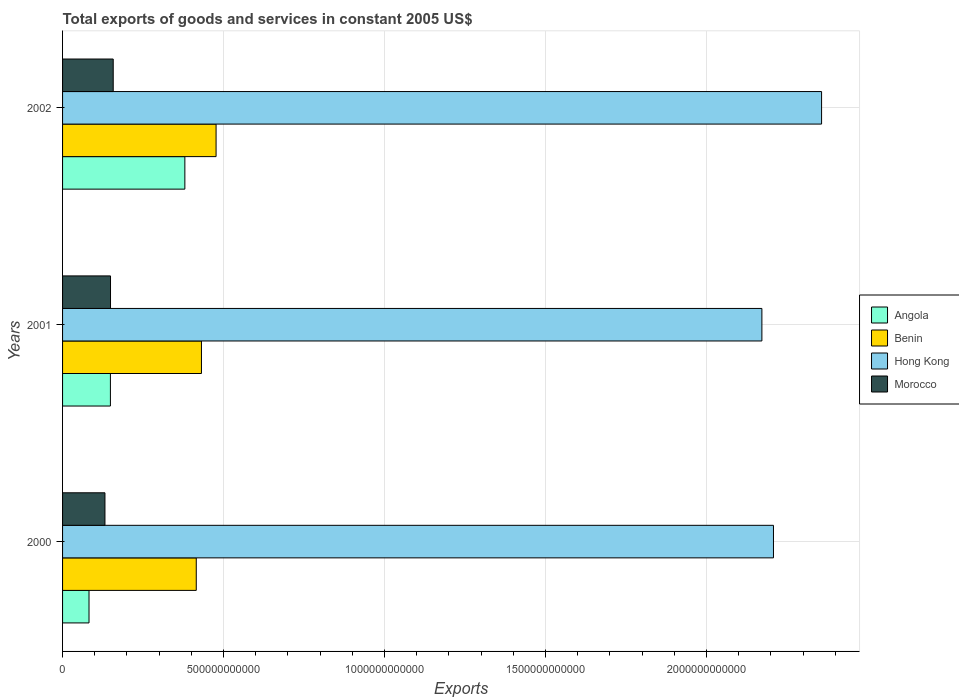How many different coloured bars are there?
Give a very brief answer. 4. How many groups of bars are there?
Your response must be concise. 3. Are the number of bars per tick equal to the number of legend labels?
Keep it short and to the point. Yes. What is the label of the 2nd group of bars from the top?
Make the answer very short. 2001. What is the total exports of goods and services in Benin in 2000?
Offer a very short reply. 4.15e+11. Across all years, what is the maximum total exports of goods and services in Benin?
Provide a short and direct response. 4.77e+11. Across all years, what is the minimum total exports of goods and services in Hong Kong?
Make the answer very short. 2.17e+12. In which year was the total exports of goods and services in Hong Kong maximum?
Make the answer very short. 2002. What is the total total exports of goods and services in Hong Kong in the graph?
Your answer should be very brief. 6.74e+12. What is the difference between the total exports of goods and services in Angola in 2000 and that in 2002?
Your answer should be very brief. -2.98e+11. What is the difference between the total exports of goods and services in Benin in 2001 and the total exports of goods and services in Morocco in 2002?
Your answer should be very brief. 2.74e+11. What is the average total exports of goods and services in Hong Kong per year?
Provide a short and direct response. 2.25e+12. In the year 2001, what is the difference between the total exports of goods and services in Angola and total exports of goods and services in Morocco?
Offer a very short reply. -3.27e+08. What is the ratio of the total exports of goods and services in Hong Kong in 2000 to that in 2002?
Offer a very short reply. 0.94. Is the total exports of goods and services in Morocco in 2001 less than that in 2002?
Your answer should be very brief. Yes. Is the difference between the total exports of goods and services in Angola in 2000 and 2001 greater than the difference between the total exports of goods and services in Morocco in 2000 and 2001?
Offer a very short reply. No. What is the difference between the highest and the second highest total exports of goods and services in Hong Kong?
Keep it short and to the point. 1.49e+11. What is the difference between the highest and the lowest total exports of goods and services in Benin?
Your answer should be very brief. 6.15e+1. What does the 1st bar from the top in 2001 represents?
Keep it short and to the point. Morocco. What does the 2nd bar from the bottom in 2000 represents?
Provide a short and direct response. Benin. Is it the case that in every year, the sum of the total exports of goods and services in Hong Kong and total exports of goods and services in Angola is greater than the total exports of goods and services in Benin?
Your response must be concise. Yes. How many bars are there?
Your answer should be very brief. 12. How many years are there in the graph?
Provide a short and direct response. 3. What is the difference between two consecutive major ticks on the X-axis?
Provide a short and direct response. 5.00e+11. Does the graph contain any zero values?
Offer a terse response. No. Does the graph contain grids?
Your answer should be compact. Yes. Where does the legend appear in the graph?
Give a very brief answer. Center right. How many legend labels are there?
Provide a short and direct response. 4. How are the legend labels stacked?
Your response must be concise. Vertical. What is the title of the graph?
Your response must be concise. Total exports of goods and services in constant 2005 US$. Does "Armenia" appear as one of the legend labels in the graph?
Provide a short and direct response. No. What is the label or title of the X-axis?
Your answer should be compact. Exports. What is the Exports in Angola in 2000?
Offer a very short reply. 8.22e+1. What is the Exports of Benin in 2000?
Your answer should be very brief. 4.15e+11. What is the Exports of Hong Kong in 2000?
Give a very brief answer. 2.21e+12. What is the Exports of Morocco in 2000?
Make the answer very short. 1.32e+11. What is the Exports of Angola in 2001?
Make the answer very short. 1.49e+11. What is the Exports of Benin in 2001?
Make the answer very short. 4.31e+11. What is the Exports in Hong Kong in 2001?
Offer a terse response. 2.17e+12. What is the Exports in Morocco in 2001?
Your answer should be very brief. 1.49e+11. What is the Exports in Angola in 2002?
Ensure brevity in your answer.  3.80e+11. What is the Exports in Benin in 2002?
Give a very brief answer. 4.77e+11. What is the Exports in Hong Kong in 2002?
Give a very brief answer. 2.36e+12. What is the Exports in Morocco in 2002?
Your answer should be compact. 1.57e+11. Across all years, what is the maximum Exports of Angola?
Keep it short and to the point. 3.80e+11. Across all years, what is the maximum Exports in Benin?
Offer a terse response. 4.77e+11. Across all years, what is the maximum Exports of Hong Kong?
Provide a short and direct response. 2.36e+12. Across all years, what is the maximum Exports of Morocco?
Your answer should be very brief. 1.57e+11. Across all years, what is the minimum Exports of Angola?
Offer a very short reply. 8.22e+1. Across all years, what is the minimum Exports of Benin?
Provide a short and direct response. 4.15e+11. Across all years, what is the minimum Exports in Hong Kong?
Ensure brevity in your answer.  2.17e+12. Across all years, what is the minimum Exports of Morocco?
Your answer should be compact. 1.32e+11. What is the total Exports of Angola in the graph?
Your response must be concise. 6.11e+11. What is the total Exports in Benin in the graph?
Provide a short and direct response. 1.32e+12. What is the total Exports of Hong Kong in the graph?
Your answer should be very brief. 6.74e+12. What is the total Exports in Morocco in the graph?
Ensure brevity in your answer.  4.38e+11. What is the difference between the Exports of Angola in 2000 and that in 2001?
Make the answer very short. -6.64e+1. What is the difference between the Exports of Benin in 2000 and that in 2001?
Your answer should be very brief. -1.61e+1. What is the difference between the Exports in Hong Kong in 2000 and that in 2001?
Make the answer very short. 3.59e+1. What is the difference between the Exports in Morocco in 2000 and that in 2001?
Your answer should be compact. -1.73e+1. What is the difference between the Exports of Angola in 2000 and that in 2002?
Your response must be concise. -2.98e+11. What is the difference between the Exports of Benin in 2000 and that in 2002?
Provide a short and direct response. -6.15e+1. What is the difference between the Exports of Hong Kong in 2000 and that in 2002?
Keep it short and to the point. -1.49e+11. What is the difference between the Exports of Morocco in 2000 and that in 2002?
Your answer should be very brief. -2.57e+1. What is the difference between the Exports of Angola in 2001 and that in 2002?
Offer a terse response. -2.31e+11. What is the difference between the Exports of Benin in 2001 and that in 2002?
Your answer should be very brief. -4.54e+1. What is the difference between the Exports in Hong Kong in 2001 and that in 2002?
Give a very brief answer. -1.85e+11. What is the difference between the Exports of Morocco in 2001 and that in 2002?
Provide a short and direct response. -8.42e+09. What is the difference between the Exports of Angola in 2000 and the Exports of Benin in 2001?
Provide a succinct answer. -3.49e+11. What is the difference between the Exports of Angola in 2000 and the Exports of Hong Kong in 2001?
Keep it short and to the point. -2.09e+12. What is the difference between the Exports in Angola in 2000 and the Exports in Morocco in 2001?
Offer a very short reply. -6.68e+1. What is the difference between the Exports in Benin in 2000 and the Exports in Hong Kong in 2001?
Provide a short and direct response. -1.76e+12. What is the difference between the Exports of Benin in 2000 and the Exports of Morocco in 2001?
Your response must be concise. 2.66e+11. What is the difference between the Exports in Hong Kong in 2000 and the Exports in Morocco in 2001?
Give a very brief answer. 2.06e+12. What is the difference between the Exports of Angola in 2000 and the Exports of Benin in 2002?
Offer a very short reply. -3.95e+11. What is the difference between the Exports in Angola in 2000 and the Exports in Hong Kong in 2002?
Keep it short and to the point. -2.28e+12. What is the difference between the Exports in Angola in 2000 and the Exports in Morocco in 2002?
Keep it short and to the point. -7.52e+1. What is the difference between the Exports in Benin in 2000 and the Exports in Hong Kong in 2002?
Provide a short and direct response. -1.94e+12. What is the difference between the Exports in Benin in 2000 and the Exports in Morocco in 2002?
Give a very brief answer. 2.58e+11. What is the difference between the Exports in Hong Kong in 2000 and the Exports in Morocco in 2002?
Make the answer very short. 2.05e+12. What is the difference between the Exports in Angola in 2001 and the Exports in Benin in 2002?
Offer a very short reply. -3.28e+11. What is the difference between the Exports of Angola in 2001 and the Exports of Hong Kong in 2002?
Provide a short and direct response. -2.21e+12. What is the difference between the Exports in Angola in 2001 and the Exports in Morocco in 2002?
Your answer should be very brief. -8.75e+09. What is the difference between the Exports of Benin in 2001 and the Exports of Hong Kong in 2002?
Provide a short and direct response. -1.93e+12. What is the difference between the Exports in Benin in 2001 and the Exports in Morocco in 2002?
Provide a succinct answer. 2.74e+11. What is the difference between the Exports in Hong Kong in 2001 and the Exports in Morocco in 2002?
Keep it short and to the point. 2.01e+12. What is the average Exports of Angola per year?
Provide a succinct answer. 2.04e+11. What is the average Exports in Benin per year?
Give a very brief answer. 4.41e+11. What is the average Exports of Hong Kong per year?
Provide a short and direct response. 2.25e+12. What is the average Exports of Morocco per year?
Your answer should be compact. 1.46e+11. In the year 2000, what is the difference between the Exports of Angola and Exports of Benin?
Your answer should be very brief. -3.33e+11. In the year 2000, what is the difference between the Exports of Angola and Exports of Hong Kong?
Offer a terse response. -2.13e+12. In the year 2000, what is the difference between the Exports of Angola and Exports of Morocco?
Give a very brief answer. -4.95e+1. In the year 2000, what is the difference between the Exports of Benin and Exports of Hong Kong?
Ensure brevity in your answer.  -1.79e+12. In the year 2000, what is the difference between the Exports of Benin and Exports of Morocco?
Your answer should be compact. 2.84e+11. In the year 2000, what is the difference between the Exports in Hong Kong and Exports in Morocco?
Keep it short and to the point. 2.08e+12. In the year 2001, what is the difference between the Exports in Angola and Exports in Benin?
Provide a succinct answer. -2.83e+11. In the year 2001, what is the difference between the Exports of Angola and Exports of Hong Kong?
Your answer should be compact. -2.02e+12. In the year 2001, what is the difference between the Exports in Angola and Exports in Morocco?
Your response must be concise. -3.27e+08. In the year 2001, what is the difference between the Exports in Benin and Exports in Hong Kong?
Offer a very short reply. -1.74e+12. In the year 2001, what is the difference between the Exports in Benin and Exports in Morocco?
Offer a very short reply. 2.82e+11. In the year 2001, what is the difference between the Exports of Hong Kong and Exports of Morocco?
Ensure brevity in your answer.  2.02e+12. In the year 2002, what is the difference between the Exports of Angola and Exports of Benin?
Make the answer very short. -9.70e+1. In the year 2002, what is the difference between the Exports in Angola and Exports in Hong Kong?
Your response must be concise. -1.98e+12. In the year 2002, what is the difference between the Exports in Angola and Exports in Morocco?
Make the answer very short. 2.22e+11. In the year 2002, what is the difference between the Exports of Benin and Exports of Hong Kong?
Offer a very short reply. -1.88e+12. In the year 2002, what is the difference between the Exports of Benin and Exports of Morocco?
Offer a very short reply. 3.19e+11. In the year 2002, what is the difference between the Exports in Hong Kong and Exports in Morocco?
Your answer should be very brief. 2.20e+12. What is the ratio of the Exports in Angola in 2000 to that in 2001?
Make the answer very short. 0.55. What is the ratio of the Exports of Benin in 2000 to that in 2001?
Offer a terse response. 0.96. What is the ratio of the Exports of Hong Kong in 2000 to that in 2001?
Ensure brevity in your answer.  1.02. What is the ratio of the Exports in Morocco in 2000 to that in 2001?
Offer a very short reply. 0.88. What is the ratio of the Exports in Angola in 2000 to that in 2002?
Provide a succinct answer. 0.22. What is the ratio of the Exports in Benin in 2000 to that in 2002?
Offer a very short reply. 0.87. What is the ratio of the Exports of Hong Kong in 2000 to that in 2002?
Keep it short and to the point. 0.94. What is the ratio of the Exports in Morocco in 2000 to that in 2002?
Your response must be concise. 0.84. What is the ratio of the Exports in Angola in 2001 to that in 2002?
Provide a succinct answer. 0.39. What is the ratio of the Exports of Benin in 2001 to that in 2002?
Make the answer very short. 0.9. What is the ratio of the Exports of Hong Kong in 2001 to that in 2002?
Give a very brief answer. 0.92. What is the ratio of the Exports in Morocco in 2001 to that in 2002?
Give a very brief answer. 0.95. What is the difference between the highest and the second highest Exports in Angola?
Your answer should be very brief. 2.31e+11. What is the difference between the highest and the second highest Exports in Benin?
Keep it short and to the point. 4.54e+1. What is the difference between the highest and the second highest Exports of Hong Kong?
Your response must be concise. 1.49e+11. What is the difference between the highest and the second highest Exports of Morocco?
Provide a short and direct response. 8.42e+09. What is the difference between the highest and the lowest Exports in Angola?
Your response must be concise. 2.98e+11. What is the difference between the highest and the lowest Exports in Benin?
Provide a succinct answer. 6.15e+1. What is the difference between the highest and the lowest Exports in Hong Kong?
Your answer should be compact. 1.85e+11. What is the difference between the highest and the lowest Exports of Morocco?
Offer a terse response. 2.57e+1. 